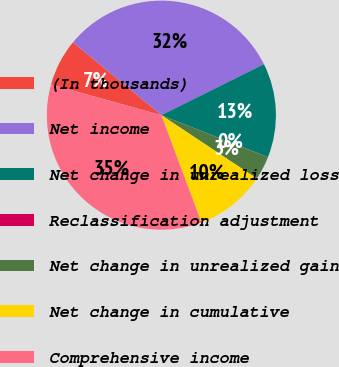Convert chart to OTSL. <chart><loc_0><loc_0><loc_500><loc_500><pie_chart><fcel>(In thousands)<fcel>Net income<fcel>Net change in unrealized loss<fcel>Reclassification adjustment<fcel>Net change in unrealized gain<fcel>Net change in cumulative<fcel>Comprehensive income<nl><fcel>6.66%<fcel>31.68%<fcel>13.31%<fcel>0.02%<fcel>3.34%<fcel>9.99%<fcel>35.0%<nl></chart> 